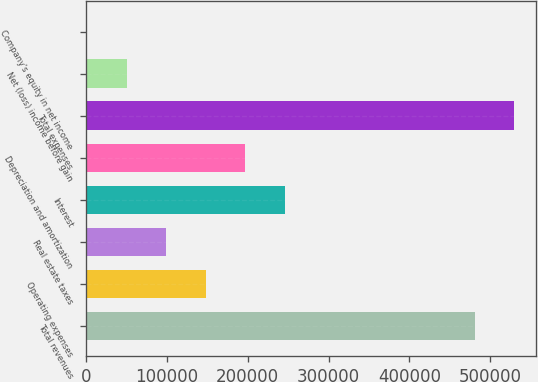Convert chart to OTSL. <chart><loc_0><loc_0><loc_500><loc_500><bar_chart><fcel>Total revenues<fcel>Operating expenses<fcel>Real estate taxes<fcel>Interest<fcel>Depreciation and amortization<fcel>Total expenses<fcel>Net (loss) income before gain<fcel>Company's equity in net income<nl><fcel>480935<fcel>148156<fcel>99298.2<fcel>245871<fcel>197013<fcel>529793<fcel>50440.6<fcel>1583<nl></chart> 